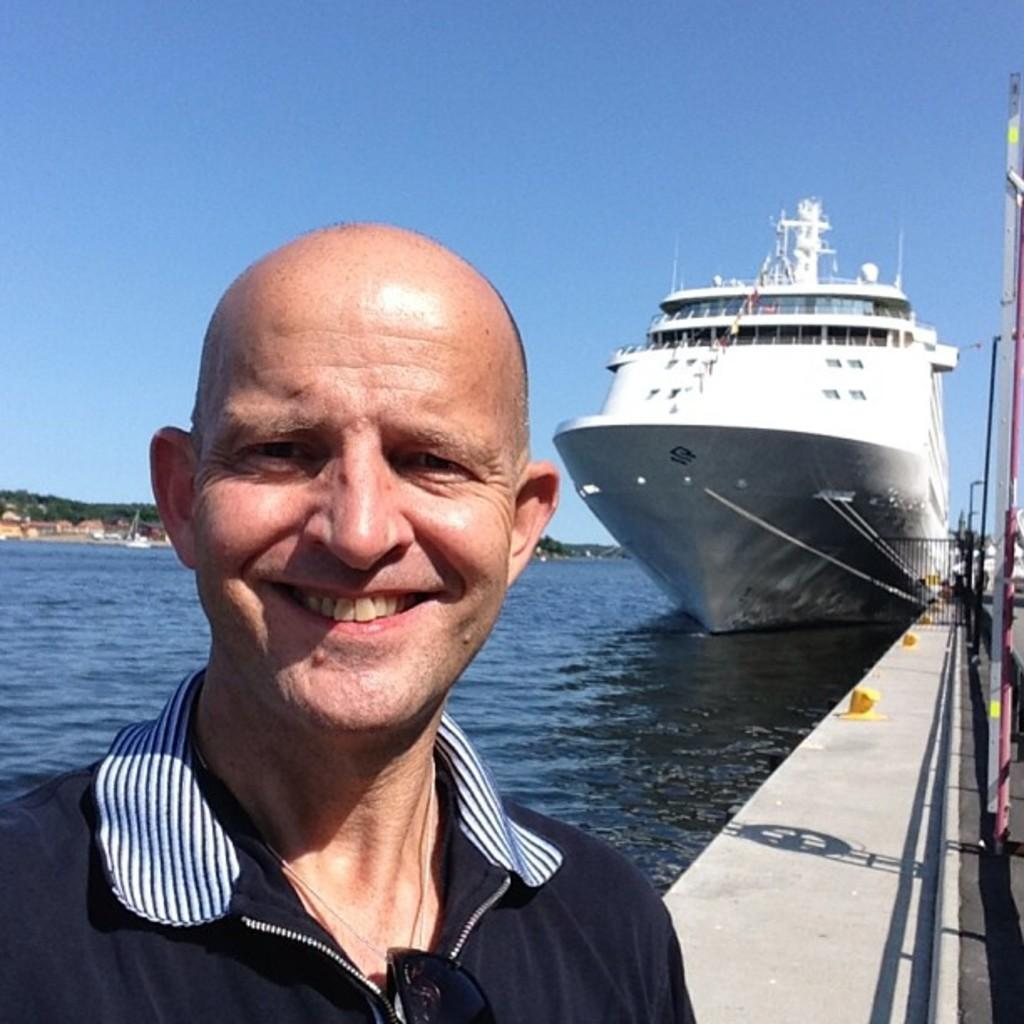What can be seen in the background of the image? The sky is visible in the image. Who or what is present in the image? There is a person in the image. What type of natural feature is in the image? There is a sea in the image. What is the person on or near in the image? There is a ship in the image. What is the composition of the image regarding the right side? There are objects truncated to the right of the image. What type of belief is depicted in the image? There is no depiction of a belief in the image; it features a person, a ship, a sea, and a sky. What type of grain can be seen in the image? There is no grain present in the image. 